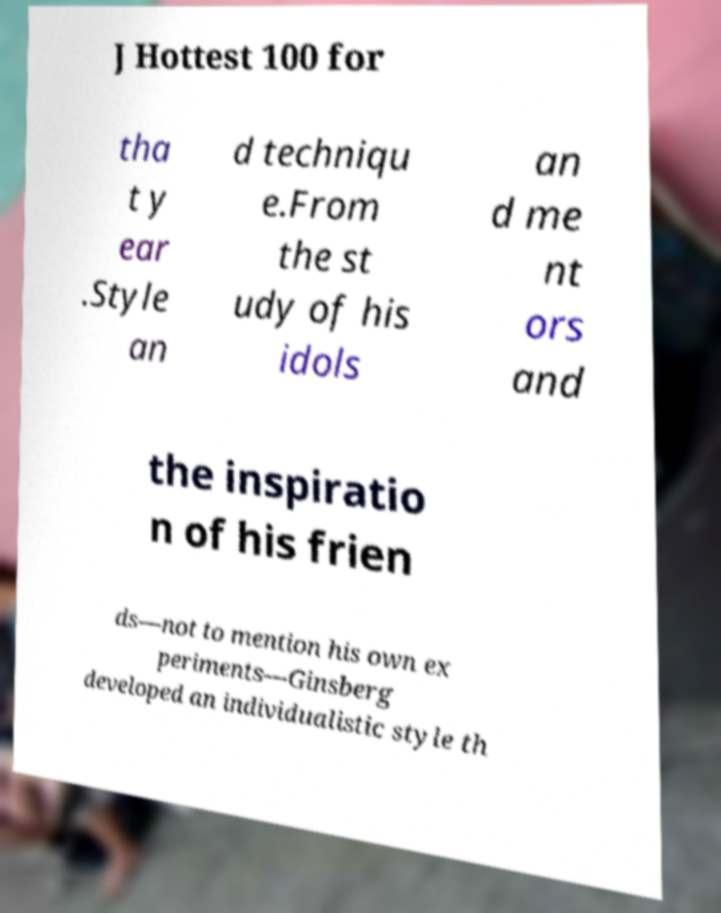Could you extract and type out the text from this image? J Hottest 100 for tha t y ear .Style an d techniqu e.From the st udy of his idols an d me nt ors and the inspiratio n of his frien ds—not to mention his own ex periments—Ginsberg developed an individualistic style th 